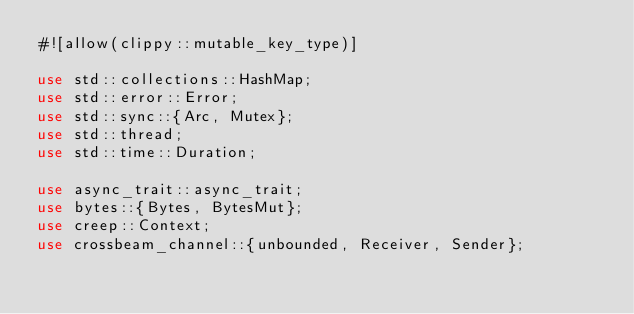<code> <loc_0><loc_0><loc_500><loc_500><_Rust_>#![allow(clippy::mutable_key_type)]

use std::collections::HashMap;
use std::error::Error;
use std::sync::{Arc, Mutex};
use std::thread;
use std::time::Duration;

use async_trait::async_trait;
use bytes::{Bytes, BytesMut};
use creep::Context;
use crossbeam_channel::{unbounded, Receiver, Sender};</code> 